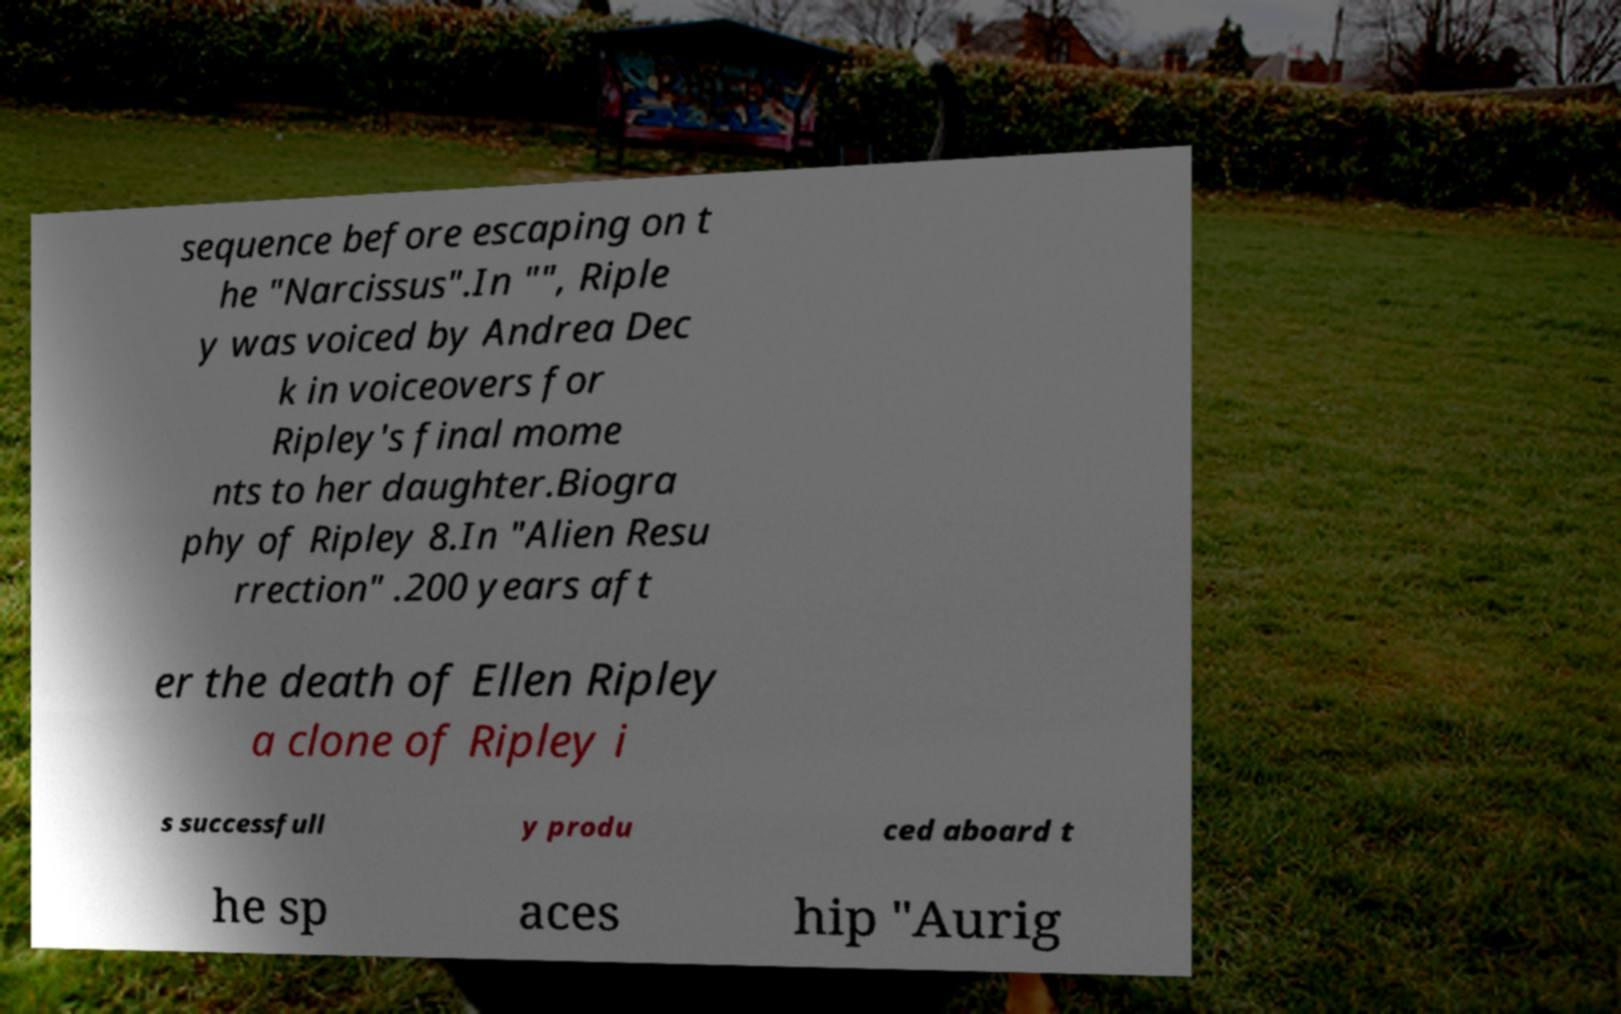Could you extract and type out the text from this image? sequence before escaping on t he "Narcissus".In "", Riple y was voiced by Andrea Dec k in voiceovers for Ripley's final mome nts to her daughter.Biogra phy of Ripley 8.In "Alien Resu rrection" .200 years aft er the death of Ellen Ripley a clone of Ripley i s successfull y produ ced aboard t he sp aces hip "Aurig 